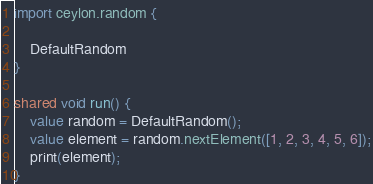Convert code to text. <code><loc_0><loc_0><loc_500><loc_500><_Ceylon_>import ceylon.random {

	DefaultRandom
}

shared void run() {
    value random = DefaultRandom();
    value element = random.nextElement([1, 2, 3, 4, 5, 6]);
    print(element);
}
</code> 